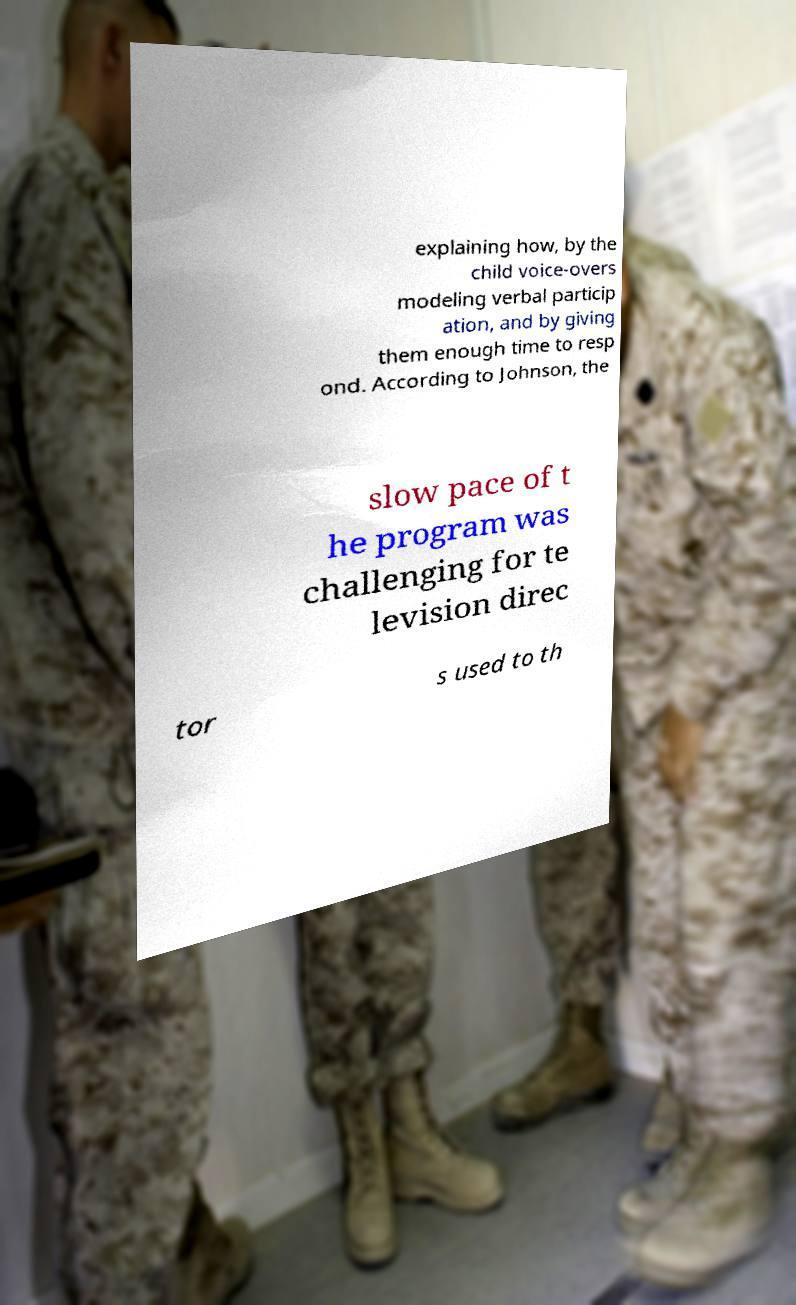For documentation purposes, I need the text within this image transcribed. Could you provide that? explaining how, by the child voice-overs modeling verbal particip ation, and by giving them enough time to resp ond. According to Johnson, the slow pace of t he program was challenging for te levision direc tor s used to th 